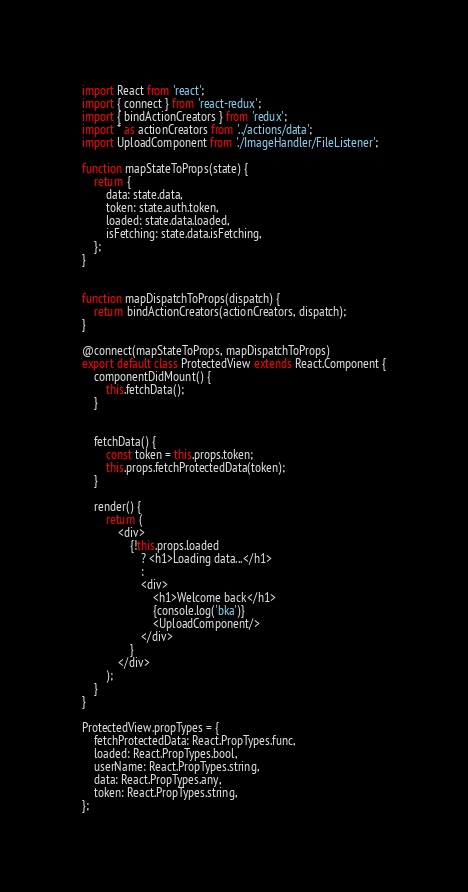<code> <loc_0><loc_0><loc_500><loc_500><_JavaScript_>import React from 'react';
import { connect } from 'react-redux';
import { bindActionCreators } from 'redux';
import * as actionCreators from '../actions/data';
import UploadComponent from './ImageHandler/FileListener';

function mapStateToProps(state) {
    return {
        data: state.data,
        token: state.auth.token,
        loaded: state.data.loaded,
        isFetching: state.data.isFetching,
    };
}


function mapDispatchToProps(dispatch) {
    return bindActionCreators(actionCreators, dispatch);
}

@connect(mapStateToProps, mapDispatchToProps)
export default class ProtectedView extends React.Component {
    componentDidMount() {
        this.fetchData();
    }


    fetchData() {
        const token = this.props.token;
        this.props.fetchProtectedData(token);
    }

    render() {
        return (
            <div>
                {!this.props.loaded
                    ? <h1>Loading data...</h1>
                    :
                    <div>
                        <h1>Welcome back</h1>
                        {console.log('bka')}
                        <UploadComponent/>
                    </div>
                }
            </div>
        );
    }
}

ProtectedView.propTypes = {
    fetchProtectedData: React.PropTypes.func,
    loaded: React.PropTypes.bool,
    userName: React.PropTypes.string,
    data: React.PropTypes.any,
    token: React.PropTypes.string,
};
</code> 